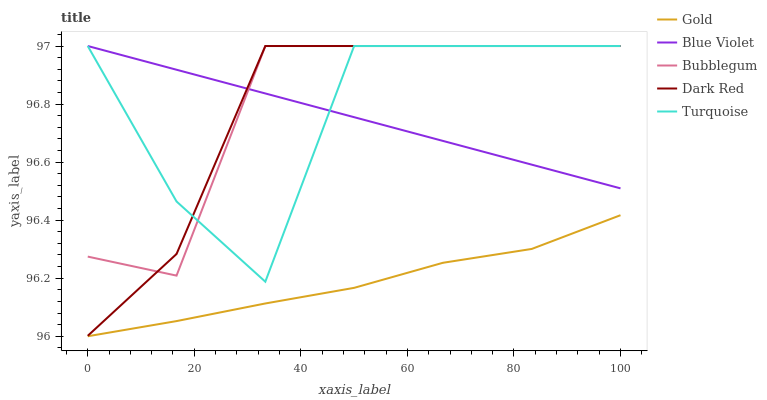Does Gold have the minimum area under the curve?
Answer yes or no. Yes. Does Bubblegum have the maximum area under the curve?
Answer yes or no. Yes. Does Turquoise have the minimum area under the curve?
Answer yes or no. No. Does Turquoise have the maximum area under the curve?
Answer yes or no. No. Is Blue Violet the smoothest?
Answer yes or no. Yes. Is Turquoise the roughest?
Answer yes or no. Yes. Is Bubblegum the smoothest?
Answer yes or no. No. Is Bubblegum the roughest?
Answer yes or no. No. Does Gold have the lowest value?
Answer yes or no. Yes. Does Turquoise have the lowest value?
Answer yes or no. No. Does Blue Violet have the highest value?
Answer yes or no. Yes. Does Gold have the highest value?
Answer yes or no. No. Is Gold less than Dark Red?
Answer yes or no. Yes. Is Dark Red greater than Gold?
Answer yes or no. Yes. Does Turquoise intersect Dark Red?
Answer yes or no. Yes. Is Turquoise less than Dark Red?
Answer yes or no. No. Is Turquoise greater than Dark Red?
Answer yes or no. No. Does Gold intersect Dark Red?
Answer yes or no. No. 